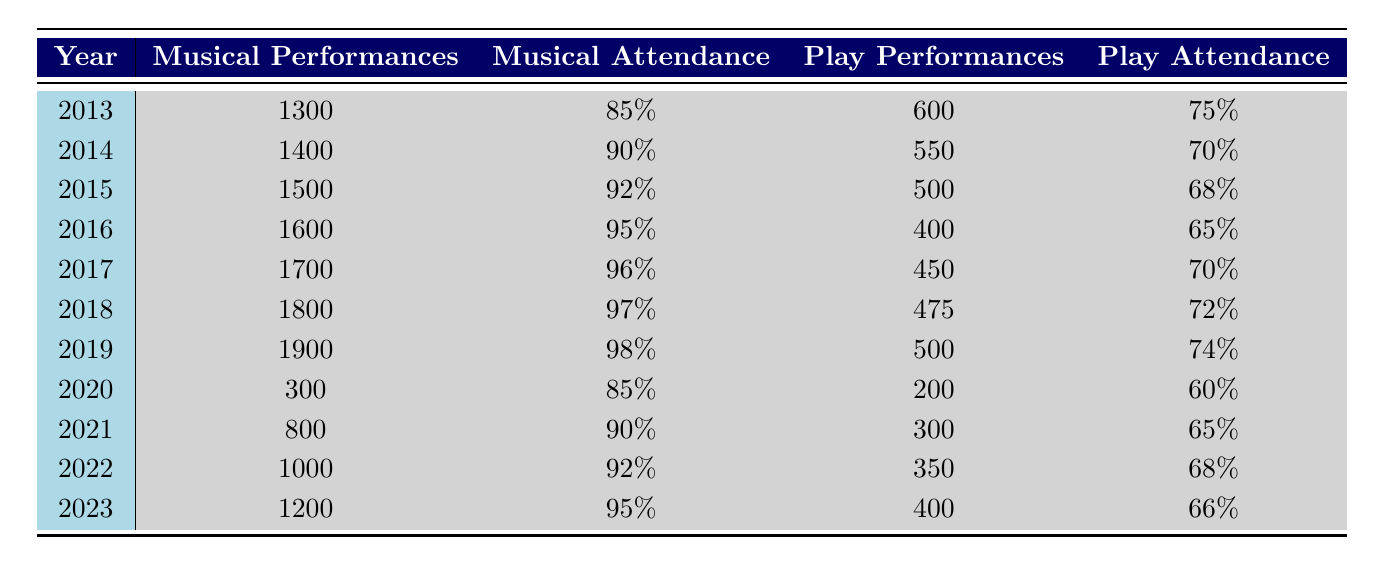What year had the highest average attendance for musicals? To find the year with the highest average attendance for musicals, I checked the "Average Attendance" column for each year. The highest attendance of 98% occurred in 2019.
Answer: 2019 What was the average gross revenue of plays over the last decade? I will sum the gross revenues of plays for all years and then divide by the number of years (10). Total gross revenue = (10,000,000 + 8,000,000 + 7,000,000 + 6,000,000 + 5,000,000 + 4,000,000 + 4,200,000 + 3,000,000 + 2,700,000 + 4,000,000) = 50,900,000. Average = 50,900,000 / 10 = 5,090,000.
Answer: 5,090,000 Did the number of musical performances increase every year? I checked each year in the "Total Performances" for musicals. The performance totals for each year are: 1300, 1400, 1500, 1600, 1700, 1800, 1900, 300, 800, 1000, 1200. There was a decrease in 2020 followed by increases in 2021 and 2022. Therefore, it is false that performances increased each year.
Answer: No Which year had the second highest gross revenue for musicals? I checked the "Gross Revenue" of musical performances for each year. The top gross revenue was 35,000,000 in 2016, and the second highest was 34,000,000 in 2019.
Answer: 2019 What was the percentage increase in total performances of plays from 2013 to 2019? I will find the total performances of plays in both years. In 2013, total performances were 600, and in 2019 they were 500. The percentage change is calculated as ((500 - 600) / 600) * 100 = -16.67%. Therefore, this is a decrease.
Answer: -16.67% 